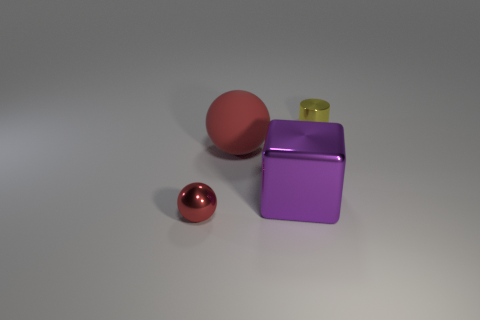What objects can be seen on the surface, and what are their textures? There are three objects on the surface: a small shiny metal sphere, a larger matte-finished sphere, and a cube with a metallic, reflective surface. The textures range from the reflective, polished finish of the small sphere and the cube, to the non-reflective, smooth surface of the larger sphere. 